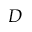Convert formula to latex. <formula><loc_0><loc_0><loc_500><loc_500>D</formula> 